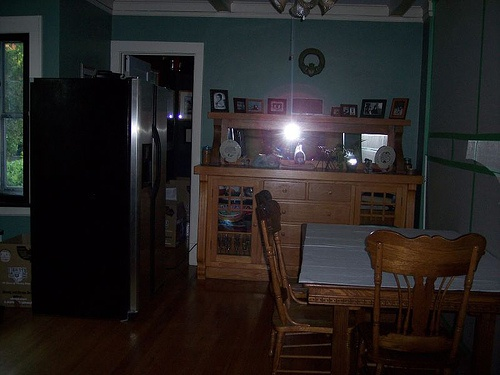Describe the objects in this image and their specific colors. I can see refrigerator in black, gray, lavender, and darkgray tones, chair in black, maroon, and gray tones, chair in black, maroon, and brown tones, refrigerator in black, gray, and darkgray tones, and dining table in black and gray tones in this image. 